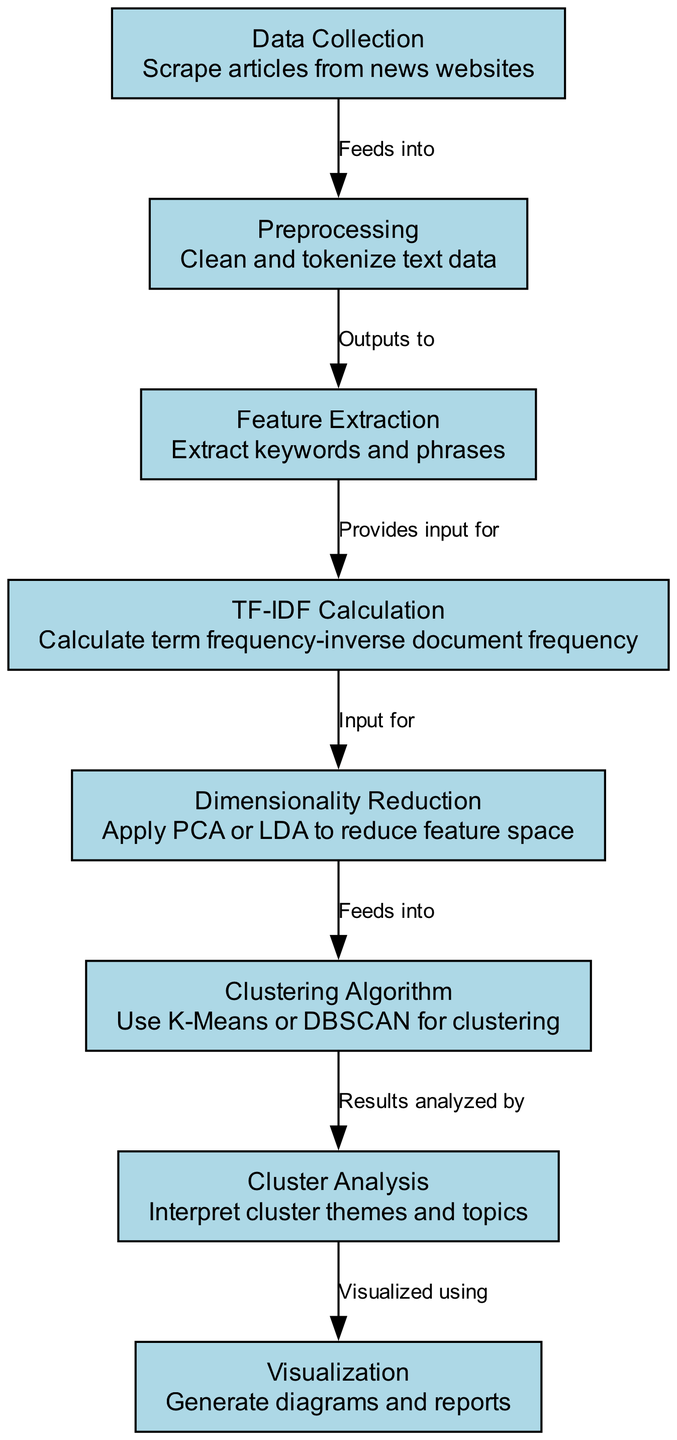What is the first node in the diagram? The first node in the diagram is labeled "Data Collection," which represents the initial stage of gathering information.
Answer: Data Collection How many nodes are present in the diagram? By counting the nodes listed in the data, there are 8 nodes that represent different stages of the machine learning process depicted in the diagram.
Answer: 8 What relationship exists between "Preprocessing" and "Feature Extraction"? The relationship between "Preprocessing" and "Feature Extraction" is described as "Outputs to," indicating that the output of the preprocessing stage provides input to the feature extraction stage.
Answer: Outputs to Which clustering algorithm is mentioned in the diagram? The diagram specifies "K-Means" and "DBSCAN" as the clustering algorithms that can be utilized for clustering the data extracted from the articles.
Answer: K-Means or DBSCAN What is the purpose of the "Dimensionality Reduction" node? The purpose of the "Dimensionality Reduction" node is to apply techniques such as PCA or LDA, which help to reduce the complexity of the feature space by condensing the information.
Answer: Reduce feature space How is cluster analysis conducted according to the diagram? Cluster analysis is conducted after the clustering algorithm has been applied, wherein the results from the clustering are analyzed to interpret the themes and topics that emerge from the clusters.
Answer: Interpret cluster themes and topics Which node follows the "Clustering Algorithm" node in the diagram? Following the "Clustering Algorithm" node, the "Cluster Analysis" node comes next, which suggests the sequence of analyzing the outcomes from the clustering process.
Answer: Cluster Analysis What type of output is generated at the final stage of the diagram? At the final stage, the diagram indicates that "Visualization" occurs, where the results of the clustering and analysis are transformed into diagrams and reports for easier understanding.
Answer: Generate diagrams and reports 